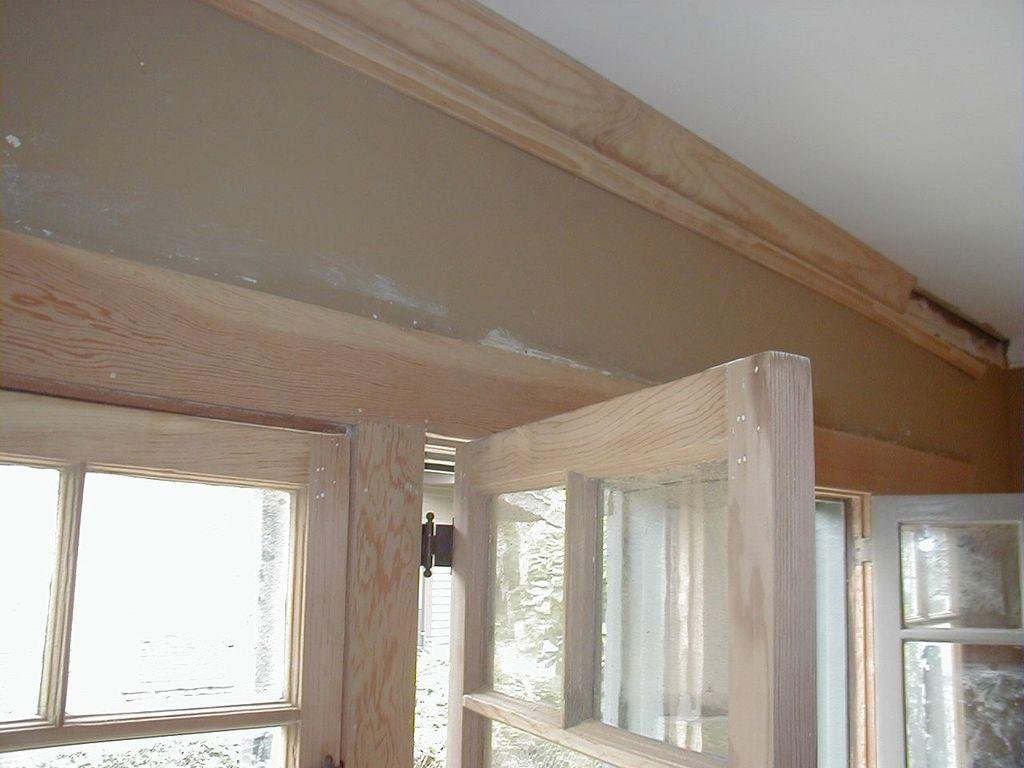What type of structure can be seen in the image? There is a door and a window in the image, which suggests a building or structure. Where are the door and window located in the image? The door and window are located at the bottom side of the image. What is visible at the top of the image? There is a roof in the image, located at the top side. How many openings are visible in the image? There is one door and one window visible in the image. What type of doctor is treating the mice in the image? There are no mice or doctors present in the image. What type of battle is taking place in the image? There is no battle or any indication of conflict in the image. 